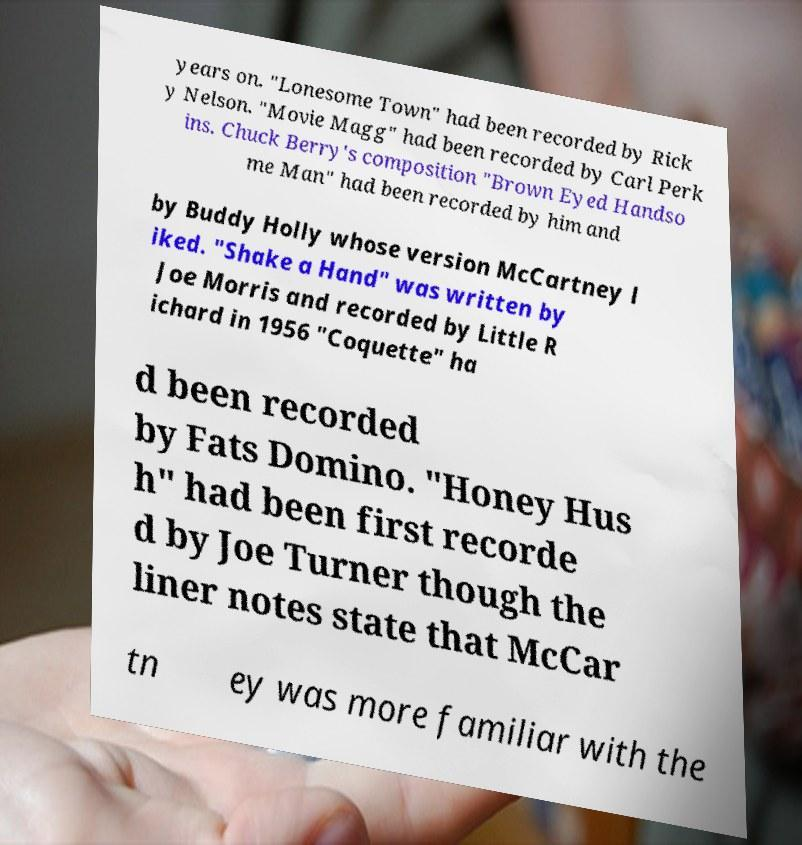Can you read and provide the text displayed in the image?This photo seems to have some interesting text. Can you extract and type it out for me? years on. "Lonesome Town" had been recorded by Rick y Nelson. "Movie Magg" had been recorded by Carl Perk ins. Chuck Berry's composition "Brown Eyed Handso me Man" had been recorded by him and by Buddy Holly whose version McCartney l iked. "Shake a Hand" was written by Joe Morris and recorded by Little R ichard in 1956 "Coquette" ha d been recorded by Fats Domino. "Honey Hus h" had been first recorde d by Joe Turner though the liner notes state that McCar tn ey was more familiar with the 